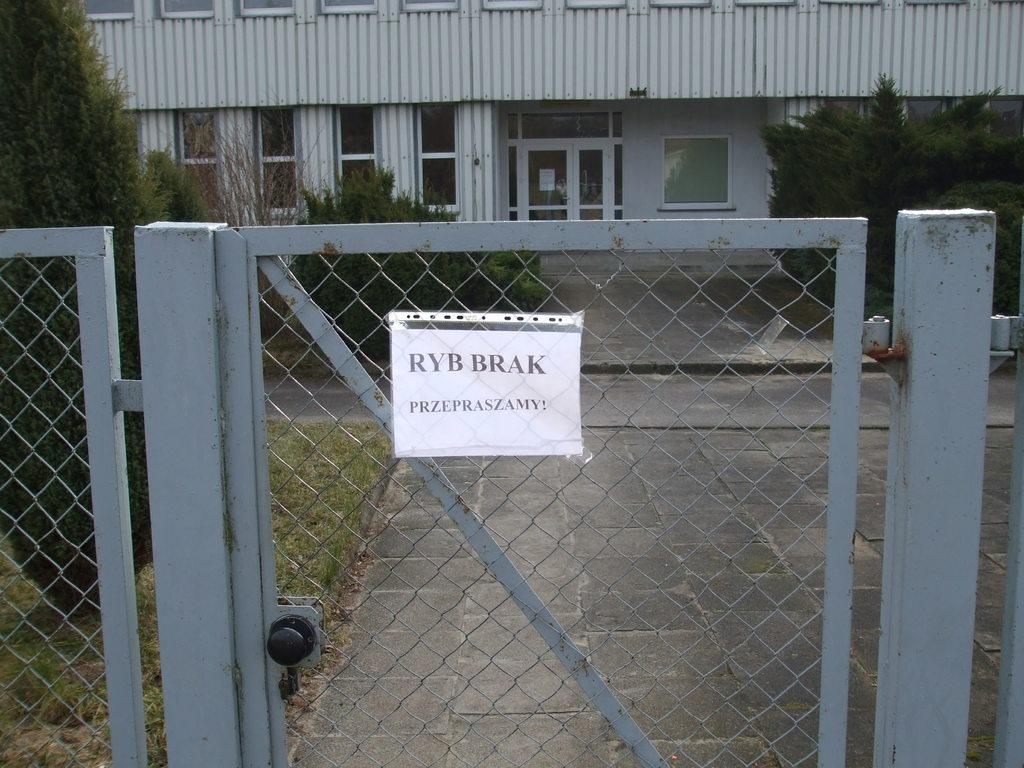What type of structures can be seen in the image? There are buildings in the image. What architectural features can be observed on the buildings? There are windows visible on the buildings. What natural elements are present in the image? There are trees in the image. What is the purpose of the gate in the image? The gate serves as an entrance or exit in the image. What is attached to the gate? A paper is attached to the gate. What is written on the paper? There is writing on the paper. What type of flame can be seen coming from the trees in the image? There is no flame present in the image; it features of the trees include leaves and branches. Who is the representative of the buildings in the image? There is no specific representative mentioned or depicted in the image. 